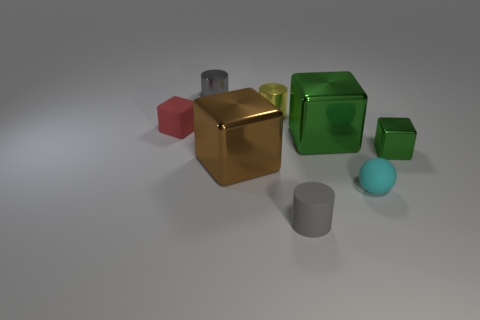Add 1 large shiny spheres. How many objects exist? 9 Subtract all tiny gray matte cylinders. How many cylinders are left? 2 Subtract all brown cubes. How many cubes are left? 3 Subtract all spheres. How many objects are left? 7 Subtract 3 cylinders. How many cylinders are left? 0 Subtract all cyan cylinders. Subtract all red cubes. How many cylinders are left? 3 Subtract all green balls. How many brown cubes are left? 1 Subtract all small rubber cylinders. Subtract all small cyan balls. How many objects are left? 6 Add 8 cyan matte things. How many cyan matte things are left? 9 Add 6 small cyan rubber balls. How many small cyan rubber balls exist? 7 